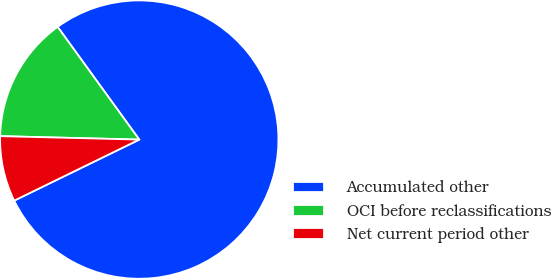Convert chart to OTSL. <chart><loc_0><loc_0><loc_500><loc_500><pie_chart><fcel>Accumulated other<fcel>OCI before reclassifications<fcel>Net current period other<nl><fcel>77.75%<fcel>14.63%<fcel>7.62%<nl></chart> 